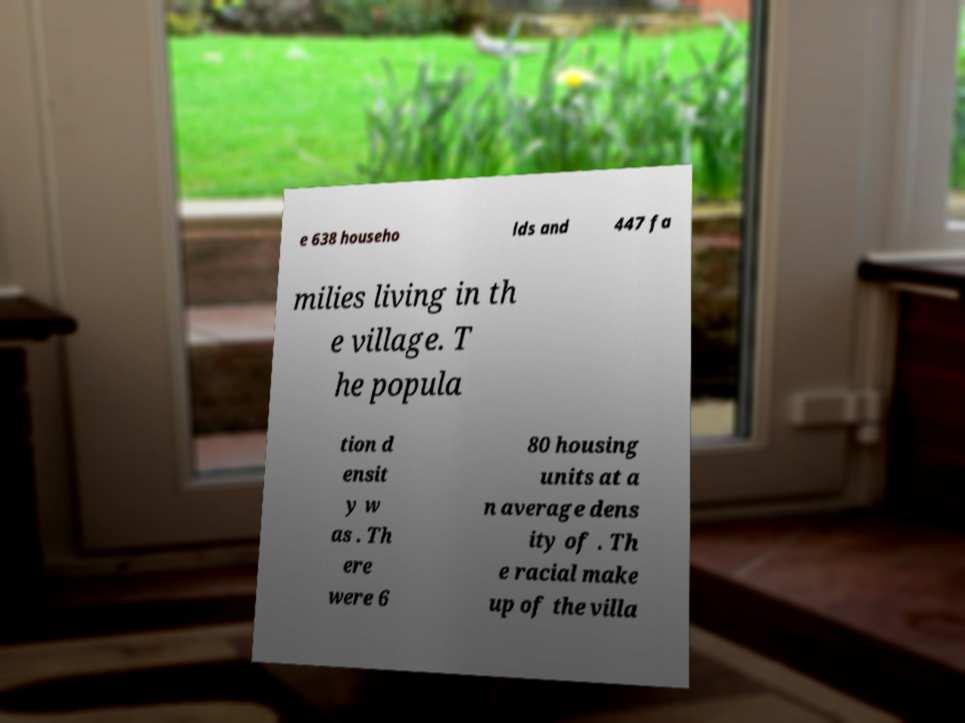Could you assist in decoding the text presented in this image and type it out clearly? e 638 househo lds and 447 fa milies living in th e village. T he popula tion d ensit y w as . Th ere were 6 80 housing units at a n average dens ity of . Th e racial make up of the villa 